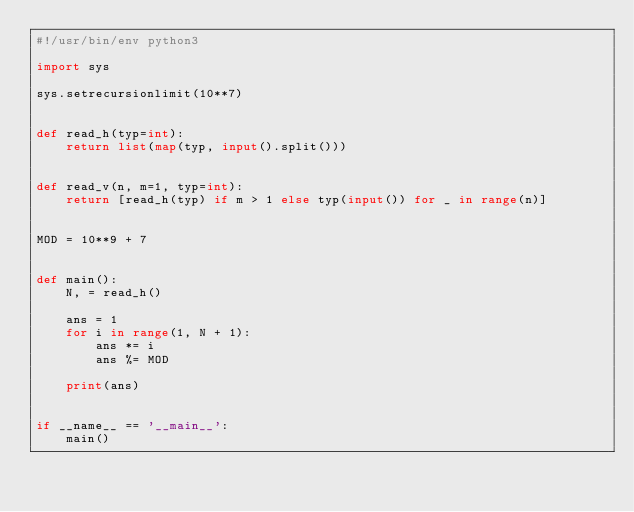<code> <loc_0><loc_0><loc_500><loc_500><_Python_>#!/usr/bin/env python3

import sys

sys.setrecursionlimit(10**7)


def read_h(typ=int):
    return list(map(typ, input().split()))


def read_v(n, m=1, typ=int):
    return [read_h(typ) if m > 1 else typ(input()) for _ in range(n)]


MOD = 10**9 + 7


def main():
    N, = read_h()

    ans = 1
    for i in range(1, N + 1):
        ans *= i
        ans %= MOD

    print(ans)


if __name__ == '__main__':
    main()
</code> 